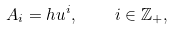<formula> <loc_0><loc_0><loc_500><loc_500>A _ { i } = h u ^ { i } , \quad i \in { \mathbb { Z } } _ { + } ,</formula> 